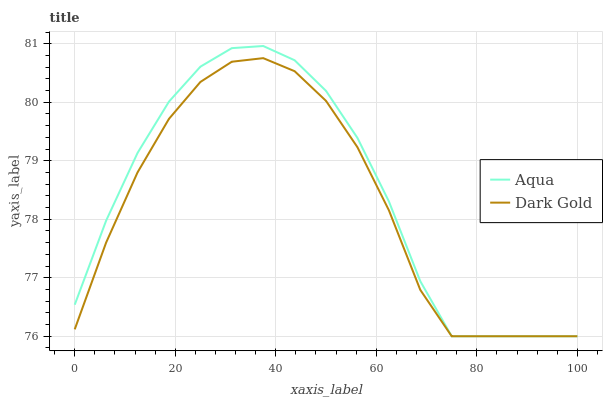Does Dark Gold have the minimum area under the curve?
Answer yes or no. Yes. Does Aqua have the maximum area under the curve?
Answer yes or no. Yes. Does Dark Gold have the maximum area under the curve?
Answer yes or no. No. Is Aqua the smoothest?
Answer yes or no. Yes. Is Dark Gold the roughest?
Answer yes or no. Yes. Is Dark Gold the smoothest?
Answer yes or no. No. Does Aqua have the lowest value?
Answer yes or no. Yes. Does Aqua have the highest value?
Answer yes or no. Yes. Does Dark Gold have the highest value?
Answer yes or no. No. Does Dark Gold intersect Aqua?
Answer yes or no. Yes. Is Dark Gold less than Aqua?
Answer yes or no. No. Is Dark Gold greater than Aqua?
Answer yes or no. No. 